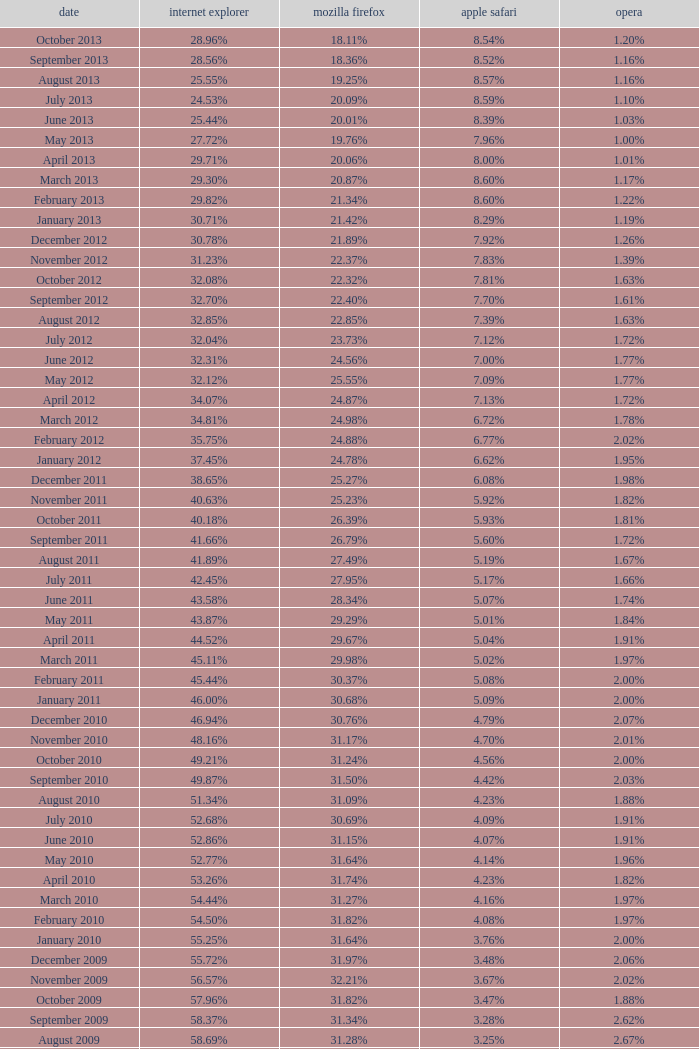What percentage of browsers were using Safari during the period in which 31.27% were using Firefox? 4.16%. 